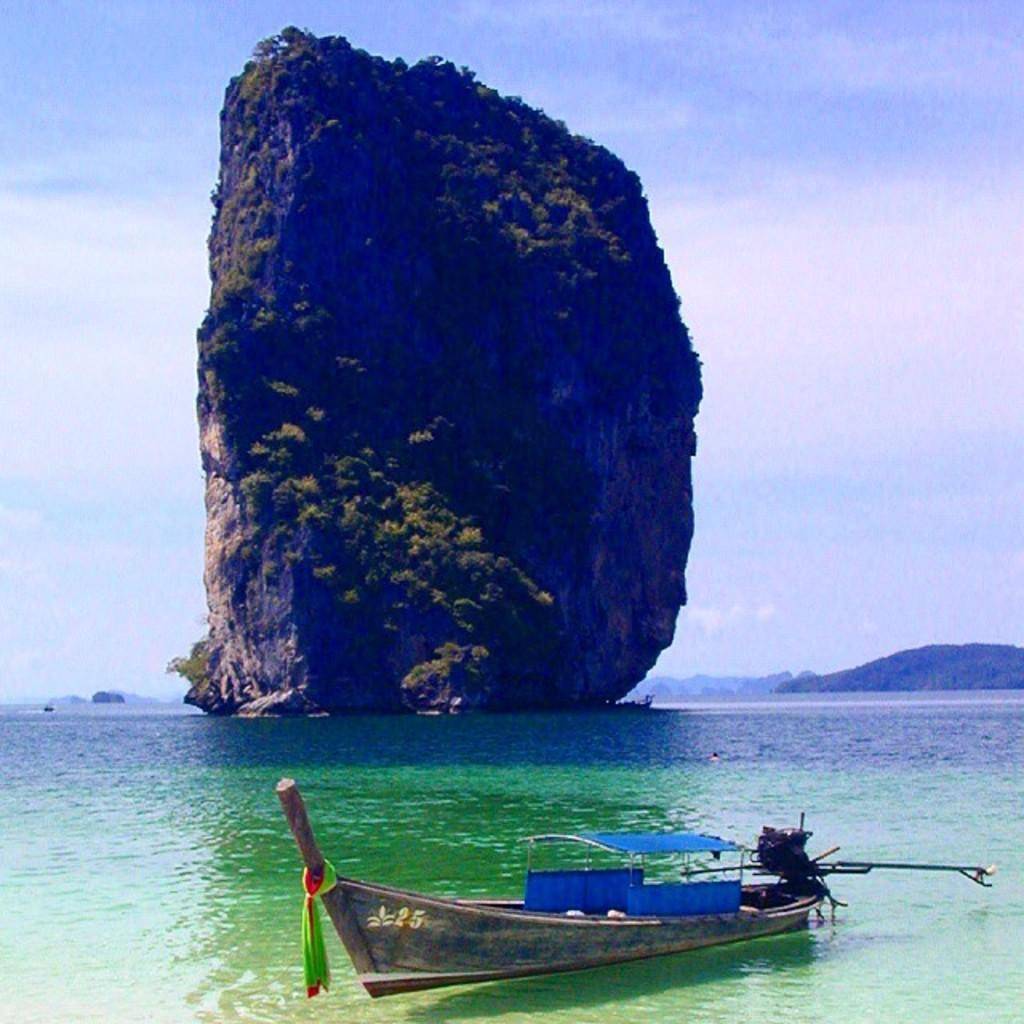What is in the water in the image? There is a boat in the water in the image. What is located in the center of the image? There is a rock in the center of the image. What type of vegetation can be seen in the image? There are trees visible in the image. What can be seen in the background of the image? There are mountains and the sky visible in the background of the image. What type of needle is being used to sew the boat in the image? There is no needle present in the image, and the boat is not being sewn. 